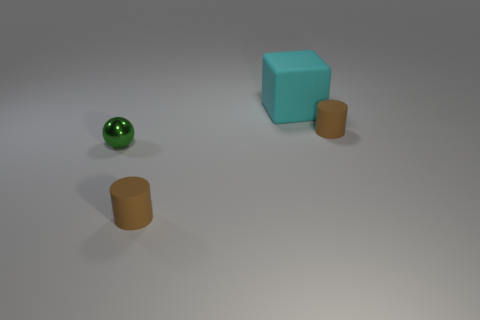What materials are the objects made of in the image? The objects in the image appear to have different materials. The cube has a matte surface, which suggests a solid, possibly painted or coated material, whereas the sphere and cylinders have a reflective surface, indicative of a metallic or glossy plastic material. 